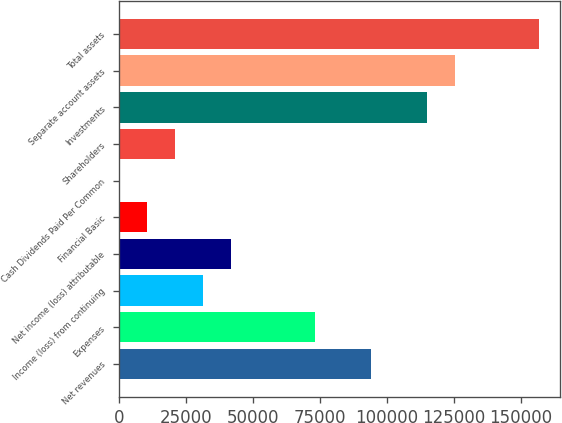Convert chart. <chart><loc_0><loc_0><loc_500><loc_500><bar_chart><fcel>Net revenues<fcel>Expenses<fcel>Income (loss) from continuing<fcel>Net income (loss) attributable<fcel>Financial Basic<fcel>Cash Dividends Paid Per Common<fcel>Shareholders<fcel>Investments<fcel>Separate account assets<fcel>Total assets<nl><fcel>93952<fcel>73073.9<fcel>31317.6<fcel>41756.7<fcel>10439.5<fcel>0.44<fcel>20878.6<fcel>114830<fcel>125269<fcel>156586<nl></chart> 